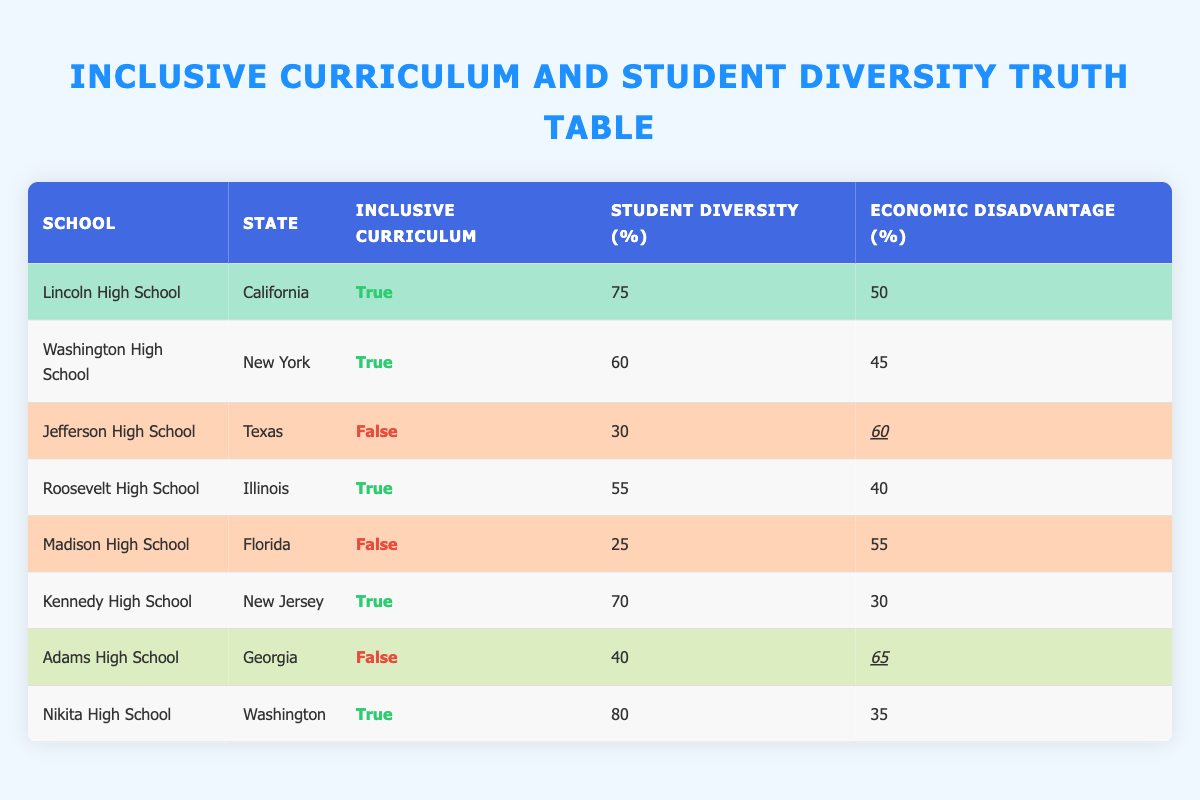What percentage of schools implemented an inclusive curriculum? Out of the eight schools listed, five (Lincoln, Washington, Roosevelt, Kennedy, and Nikita) implemented an inclusive curriculum. Therefore, to find the percentage, we use the formula (number of schools with curriculum/total number of schools) x 100. This gives us (5/8) x 100 = 62.5%.
Answer: 62.5% What is the maximum student diversity percentage among schools that did not implement an inclusive curriculum? Looking at the schools without an inclusive curriculum, Jefferson High School has 30% diversity and Madison High School has 25%. The maximum of these values is 30%.
Answer: 30% Is it true that all schools with an inclusive curriculum have at least 55% student diversity? The schools with inclusive curriculum are Lincoln (75%), Washington (60%), Roosevelt (55%), Kennedy (70%), and Nikita (80%). All these values are either equal to or greater than 55%, confirming the statement as true.
Answer: Yes How does the economic disadvantage percentage compare between schools with and without an inclusive curriculum? For schools with an inclusive curriculum, the economic disadvantage percentages are 50%, 45%, 40%, 30%, and 35% (average = 40%). For schools without, the percentages are 60%, 55%, and 65% (average = 60%). Therefore, schools without an inclusive curriculum have a higher average economic disadvantage percentage compared to those with it.
Answer: Higher for schools without What is the average student diversity percentage for schools with an inclusive curriculum? The diversity percentages for those schools are 75%, 60%, 55%, 70%, and 80%. The sum of these values is 340, and with 5 schools, the average is 340/5 = 68%.
Answer: 68% What is the combined student diversity percentage of schools that implemented an inclusive curriculum compared to those that did not? Schools with inclusive curricula have a total diversity of 340% (75% + 60% + 55% + 70% + 80%). Schools without it have 95% total (30% + 25% + 40%). Therefore, the combined total is 340% (inclusive) + 95% (non-inclusive) = 435%.
Answer: 435% Which school has the highest economic disadvantage and does not have an inclusive curriculum? Among schools that did not implement an inclusive curriculum, Jefferson High School has 60% economic disadvantage, Madison has 55%, and Adams has 65%. Therefore, Adams High School has the highest with 65%.
Answer: Adams High School Are there any schools that have an inclusive curriculum and less than 60% student racial/ethnic diversity? The inclusive schools and their diversity percentages are Lincoln (75%), Washington (60%), Roosevelt (55%), Kennedy (70%), and Nikita (80%). Since Roosevelt has only 55%, it indicates that there is at least one school that meets this condition.
Answer: Yes What percentage of the total schools is represented by the highest diversity school? The highest diversity percentage is 80% from Nikita High School. To find the percentage of total schools represented by this diversity, we consider it in relation to the total (80% out of 100%). Therefore, it represents 80% of the school’s diversity itself.
Answer: 80% 